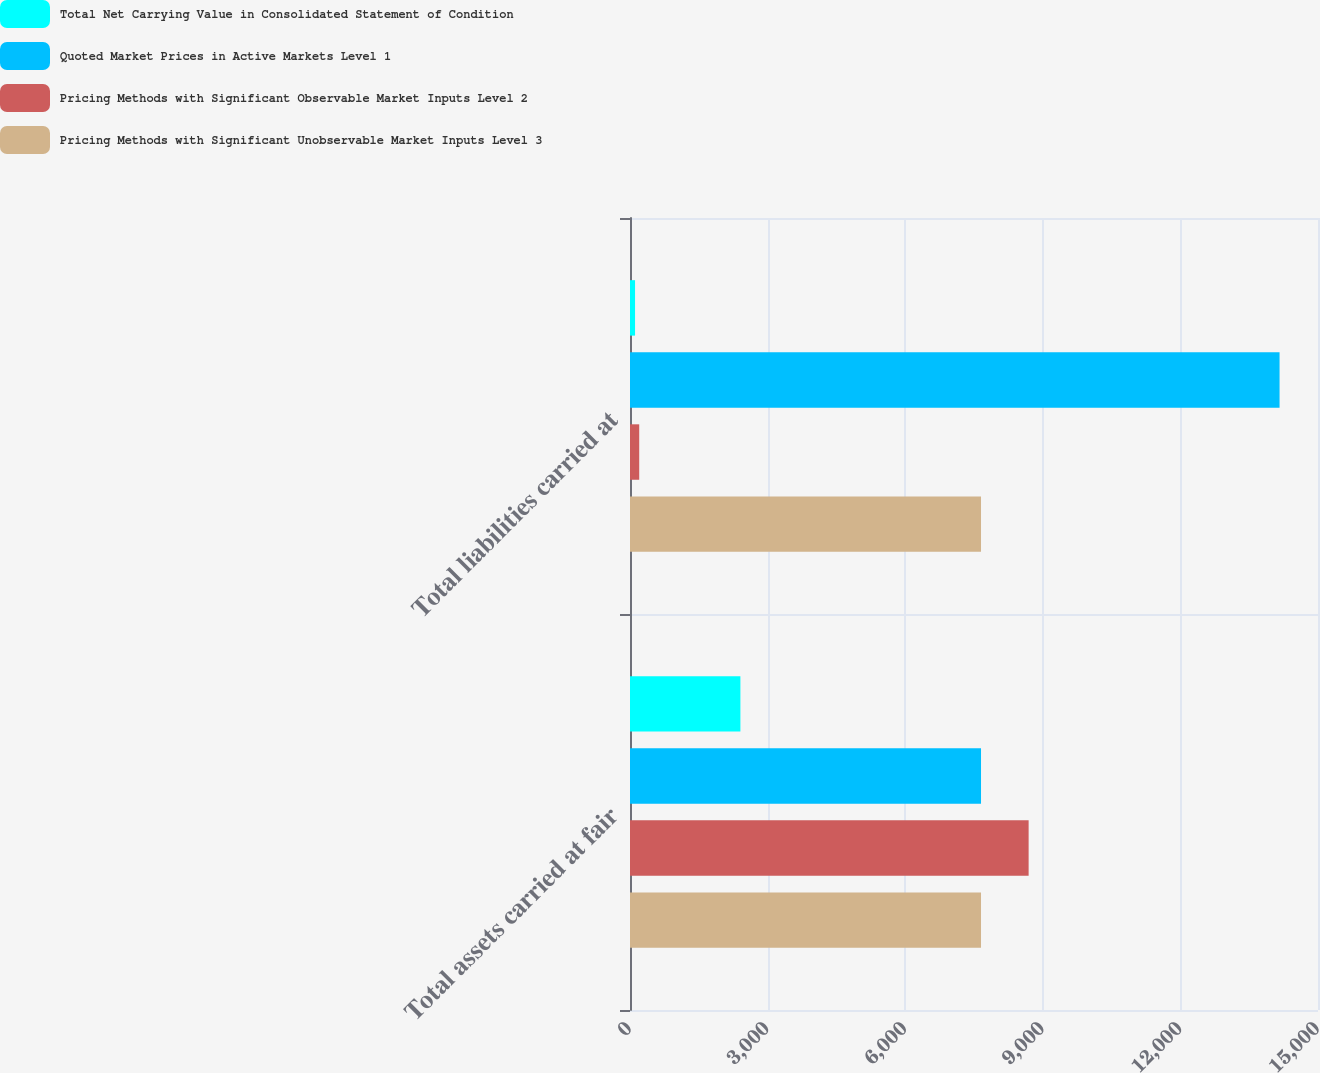<chart> <loc_0><loc_0><loc_500><loc_500><stacked_bar_chart><ecel><fcel>Total assets carried at fair<fcel>Total liabilities carried at<nl><fcel>Total Net Carrying Value in Consolidated Statement of Condition<fcel>2407<fcel>110<nl><fcel>Quoted Market Prices in Active Markets Level 1<fcel>7653<fcel>14162<nl><fcel>Pricing Methods with Significant Observable Market Inputs Level 2<fcel>8691<fcel>201<nl><fcel>Pricing Methods with Significant Unobservable Market Inputs Level 3<fcel>7653<fcel>7653<nl></chart> 